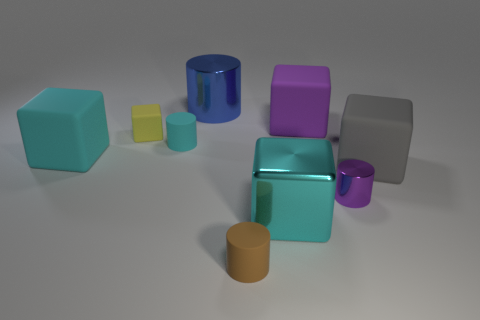Subtract all small cylinders. How many cylinders are left? 1 Add 1 blue metal spheres. How many objects exist? 10 Subtract all yellow cubes. How many cubes are left? 4 Subtract all cylinders. How many objects are left? 5 Subtract 3 cubes. How many cubes are left? 2 Add 7 purple cylinders. How many purple cylinders are left? 8 Add 6 tiny purple cylinders. How many tiny purple cylinders exist? 7 Subtract 0 blue balls. How many objects are left? 9 Subtract all purple cylinders. Subtract all cyan balls. How many cylinders are left? 3 Subtract all cyan balls. How many cyan cubes are left? 2 